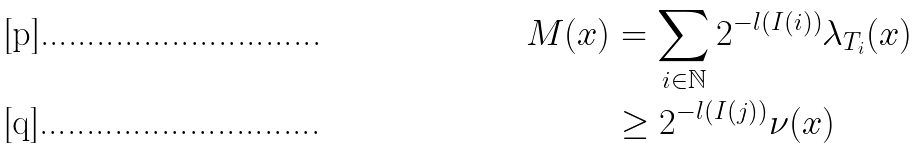<formula> <loc_0><loc_0><loc_500><loc_500>M ( x ) & = \sum _ { i \in \mathbb { N } } 2 ^ { - l ( I ( i ) ) } \lambda _ { T _ { i } } ( x ) \\ & \geq 2 ^ { - l ( I ( j ) ) } \nu ( x )</formula> 